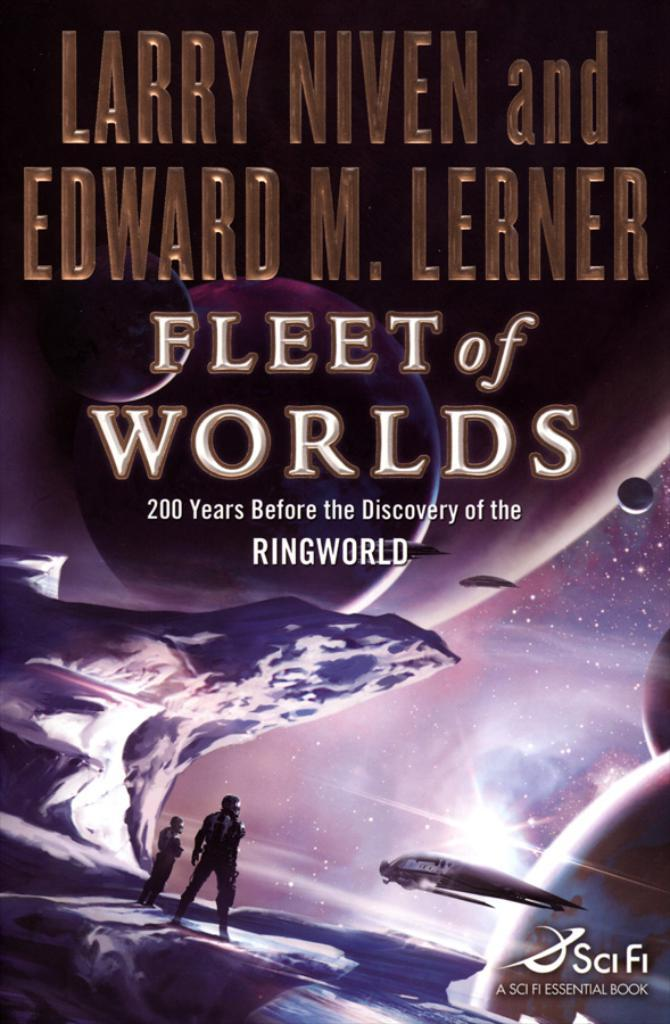<image>
Summarize the visual content of the image. A cover of the book titled fleet of worlds written by larry niven. 